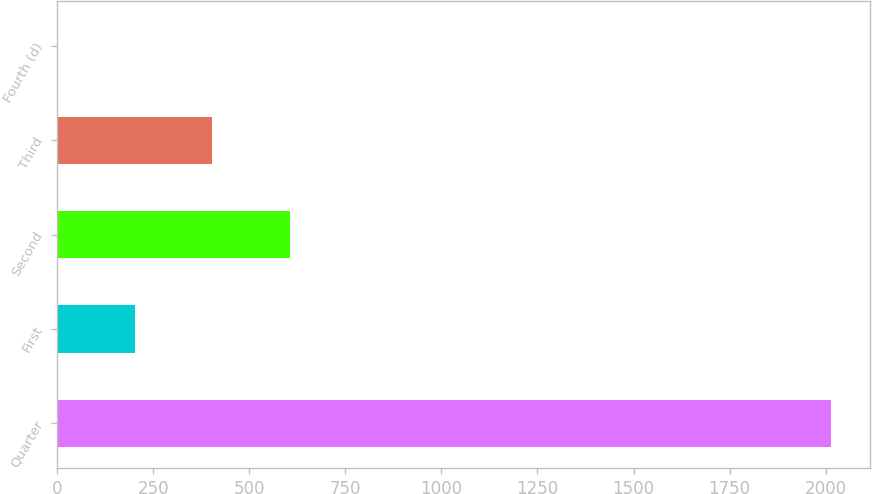Convert chart. <chart><loc_0><loc_0><loc_500><loc_500><bar_chart><fcel>Quarter<fcel>First<fcel>Second<fcel>Third<fcel>Fourth (d)<nl><fcel>2014<fcel>202.39<fcel>604.97<fcel>403.68<fcel>1.1<nl></chart> 